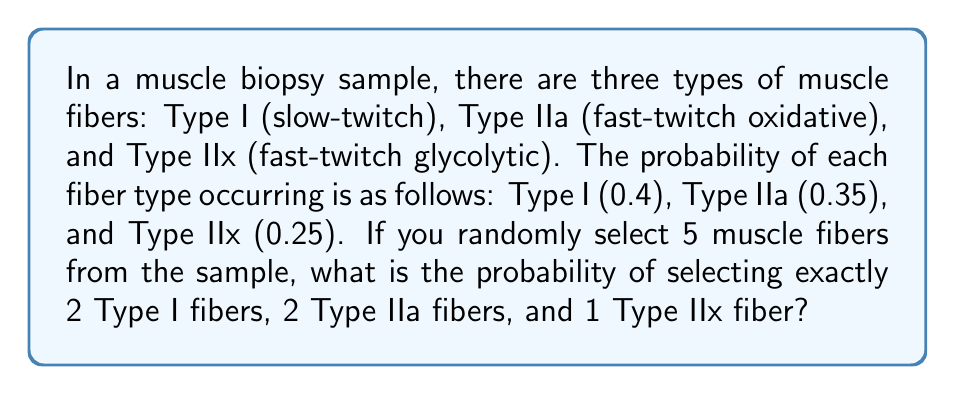Teach me how to tackle this problem. To solve this problem, we need to use the multinomial probability distribution, which is an extension of the binomial distribution for more than two outcomes.

The probability mass function for the multinomial distribution is:

$$P(X_1 = x_1, X_2 = x_2, ..., X_k = x_k) = \frac{n!}{x_1! x_2! ... x_k!} p_1^{x_1} p_2^{x_2} ... p_k^{x_k}$$

Where:
- $n$ is the total number of trials (in this case, 5 muscle fibers)
- $x_i$ is the number of occurrences of each outcome
- $p_i$ is the probability of each outcome

For our problem:
- $n = 5$
- $x_1 = 2$ (Type I), $x_2 = 2$ (Type IIa), $x_3 = 1$ (Type IIx)
- $p_1 = 0.4$ (Type I), $p_2 = 0.35$ (Type IIa), $p_3 = 0.25$ (Type IIx)

Plugging these values into the formula:

$$P(X_1 = 2, X_2 = 2, X_3 = 1) = \frac{5!}{2! 2! 1!} (0.4)^2 (0.35)^2 (0.25)^1$$

Simplifying:

$$= \frac{5 \cdot 4 \cdot 3 \cdot 2 \cdot 1}{(2 \cdot 1)(2 \cdot 1)(1)} \cdot 0.16 \cdot 0.1225 \cdot 0.25$$

$$= 60 \cdot 0.16 \cdot 0.1225 \cdot 0.25$$

$$= 60 \cdot 0.0049$$

$$= 0.294$$

Therefore, the probability of selecting exactly 2 Type I fibers, 2 Type IIa fibers, and 1 Type IIx fiber from a sample of 5 muscle fibers is approximately 0.294 or 29.4%.
Answer: 0.294 or 29.4% 